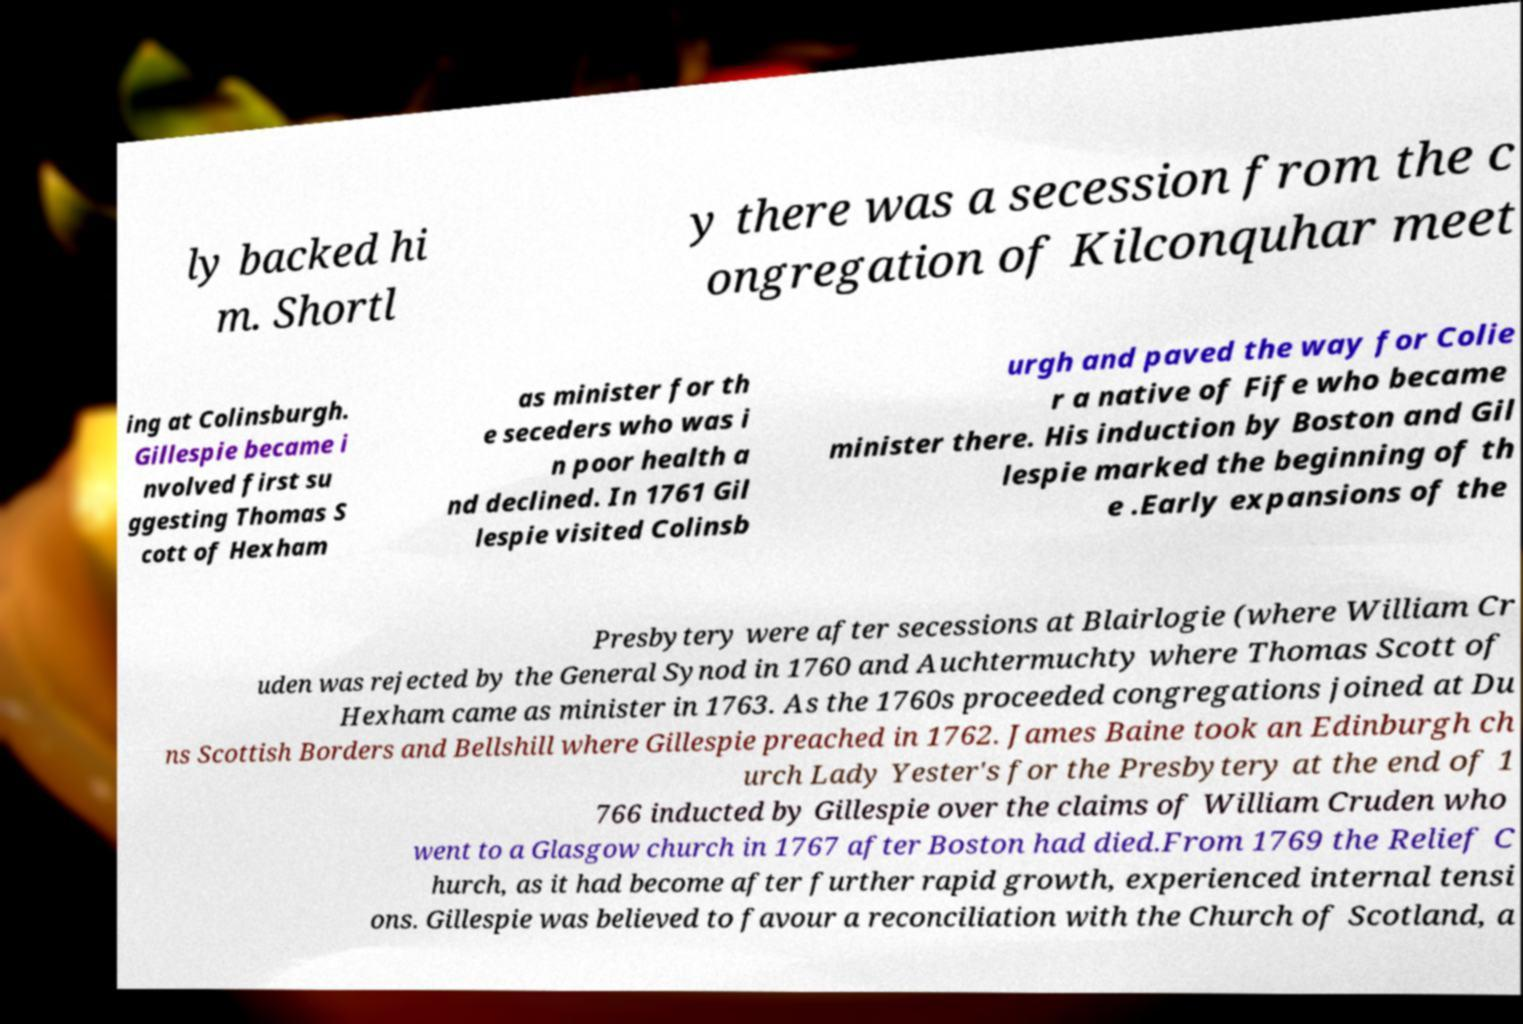I need the written content from this picture converted into text. Can you do that? ly backed hi m. Shortl y there was a secession from the c ongregation of Kilconquhar meet ing at Colinsburgh. Gillespie became i nvolved first su ggesting Thomas S cott of Hexham as minister for th e seceders who was i n poor health a nd declined. In 1761 Gil lespie visited Colinsb urgh and paved the way for Colie r a native of Fife who became minister there. His induction by Boston and Gil lespie marked the beginning of th e .Early expansions of the Presbytery were after secessions at Blairlogie (where William Cr uden was rejected by the General Synod in 1760 and Auchtermuchty where Thomas Scott of Hexham came as minister in 1763. As the 1760s proceeded congregations joined at Du ns Scottish Borders and Bellshill where Gillespie preached in 1762. James Baine took an Edinburgh ch urch Lady Yester's for the Presbytery at the end of 1 766 inducted by Gillespie over the claims of William Cruden who went to a Glasgow church in 1767 after Boston had died.From 1769 the Relief C hurch, as it had become after further rapid growth, experienced internal tensi ons. Gillespie was believed to favour a reconciliation with the Church of Scotland, a 